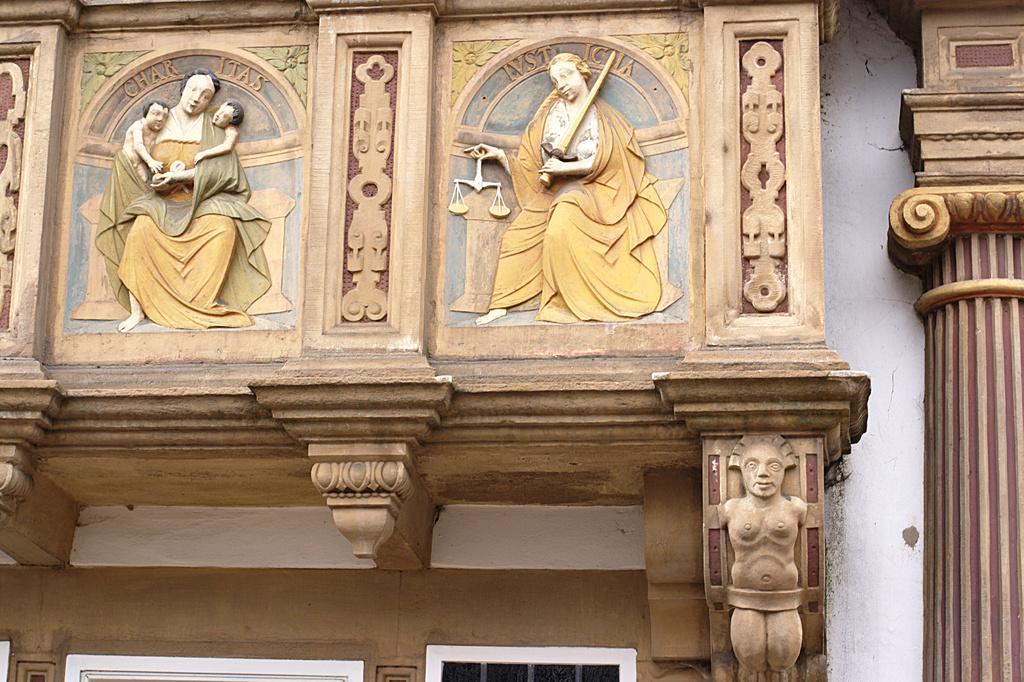In one or two sentences, can you explain what this image depicts? In this picture we can see sculptures on the wall, here we can see a pillar and some objects. 